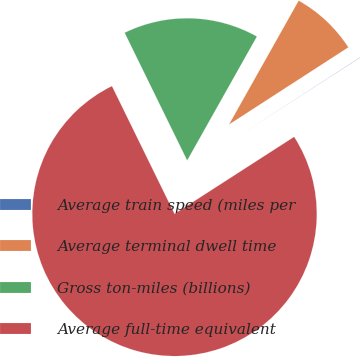Convert chart to OTSL. <chart><loc_0><loc_0><loc_500><loc_500><pie_chart><fcel>Average train speed (miles per<fcel>Average terminal dwell time<fcel>Gross ton-miles (billions)<fcel>Average full-time equivalent<nl><fcel>0.03%<fcel>7.71%<fcel>15.4%<fcel>76.86%<nl></chart> 